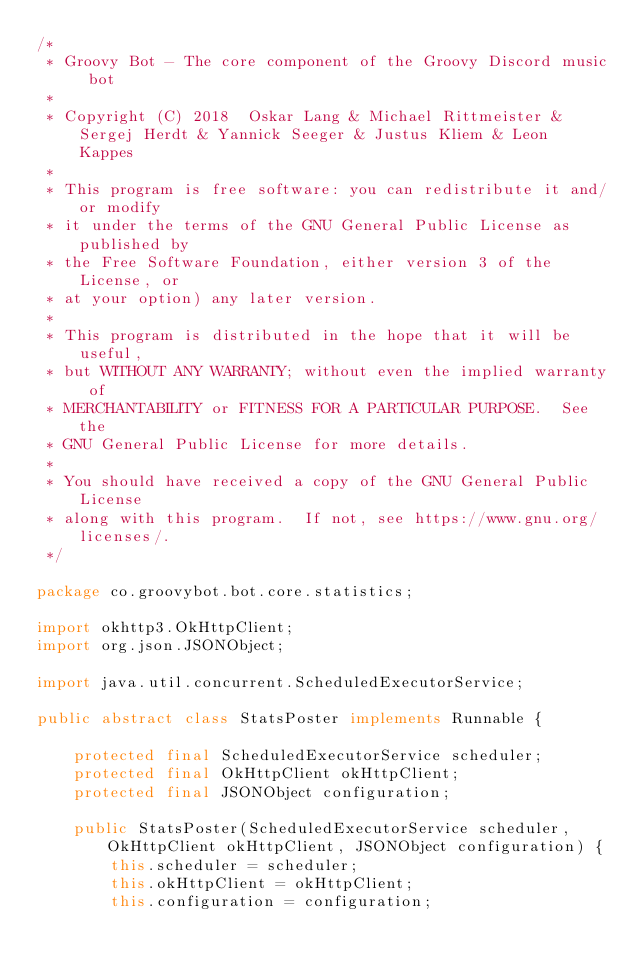Convert code to text. <code><loc_0><loc_0><loc_500><loc_500><_Java_>/*
 * Groovy Bot - The core component of the Groovy Discord music bot
 *
 * Copyright (C) 2018  Oskar Lang & Michael Rittmeister & Sergej Herdt & Yannick Seeger & Justus Kliem & Leon Kappes
 *
 * This program is free software: you can redistribute it and/or modify
 * it under the terms of the GNU General Public License as published by
 * the Free Software Foundation, either version 3 of the License, or
 * at your option) any later version.
 *
 * This program is distributed in the hope that it will be useful,
 * but WITHOUT ANY WARRANTY; without even the implied warranty of
 * MERCHANTABILITY or FITNESS FOR A PARTICULAR PURPOSE.  See the
 * GNU General Public License for more details.
 *
 * You should have received a copy of the GNU General Public License
 * along with this program.  If not, see https://www.gnu.org/licenses/.
 */

package co.groovybot.bot.core.statistics;

import okhttp3.OkHttpClient;
import org.json.JSONObject;

import java.util.concurrent.ScheduledExecutorService;

public abstract class StatsPoster implements Runnable {

    protected final ScheduledExecutorService scheduler;
    protected final OkHttpClient okHttpClient;
    protected final JSONObject configuration;

    public StatsPoster(ScheduledExecutorService scheduler, OkHttpClient okHttpClient, JSONObject configuration) {
        this.scheduler = scheduler;
        this.okHttpClient = okHttpClient;
        this.configuration = configuration;</code> 